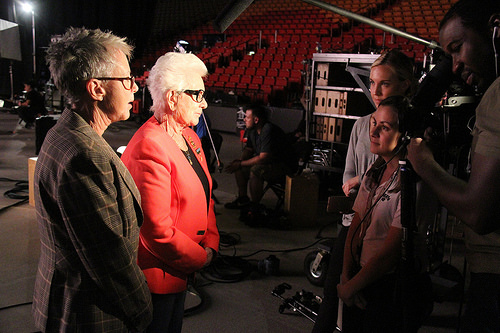<image>
Can you confirm if the camera is to the left of the girl? Yes. From this viewpoint, the camera is positioned to the left side relative to the girl. 